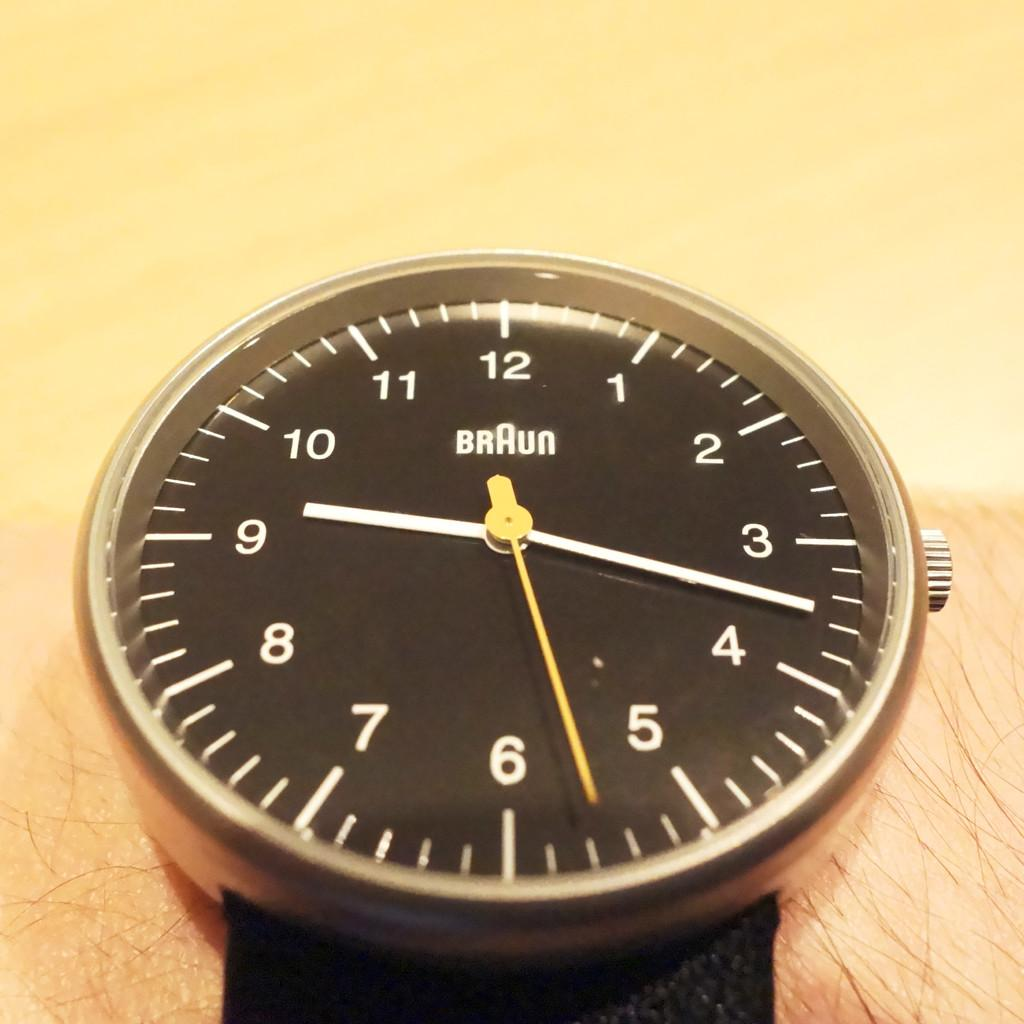<image>
Describe the image concisely. A Braun watch face is shown with the hands pointing to 9:17. 